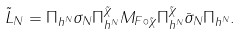Convert formula to latex. <formula><loc_0><loc_0><loc_500><loc_500>\tilde { L } _ { N } = \Pi _ { h ^ { N } } \sigma _ { N } \Pi _ { h ^ { N } } ^ { \tilde { \chi } } M _ { F \circ \tilde { \chi } } \Pi _ { h ^ { N } } ^ { \tilde { \chi } } \bar { \sigma } _ { N } \Pi _ { h ^ { N } } .</formula> 